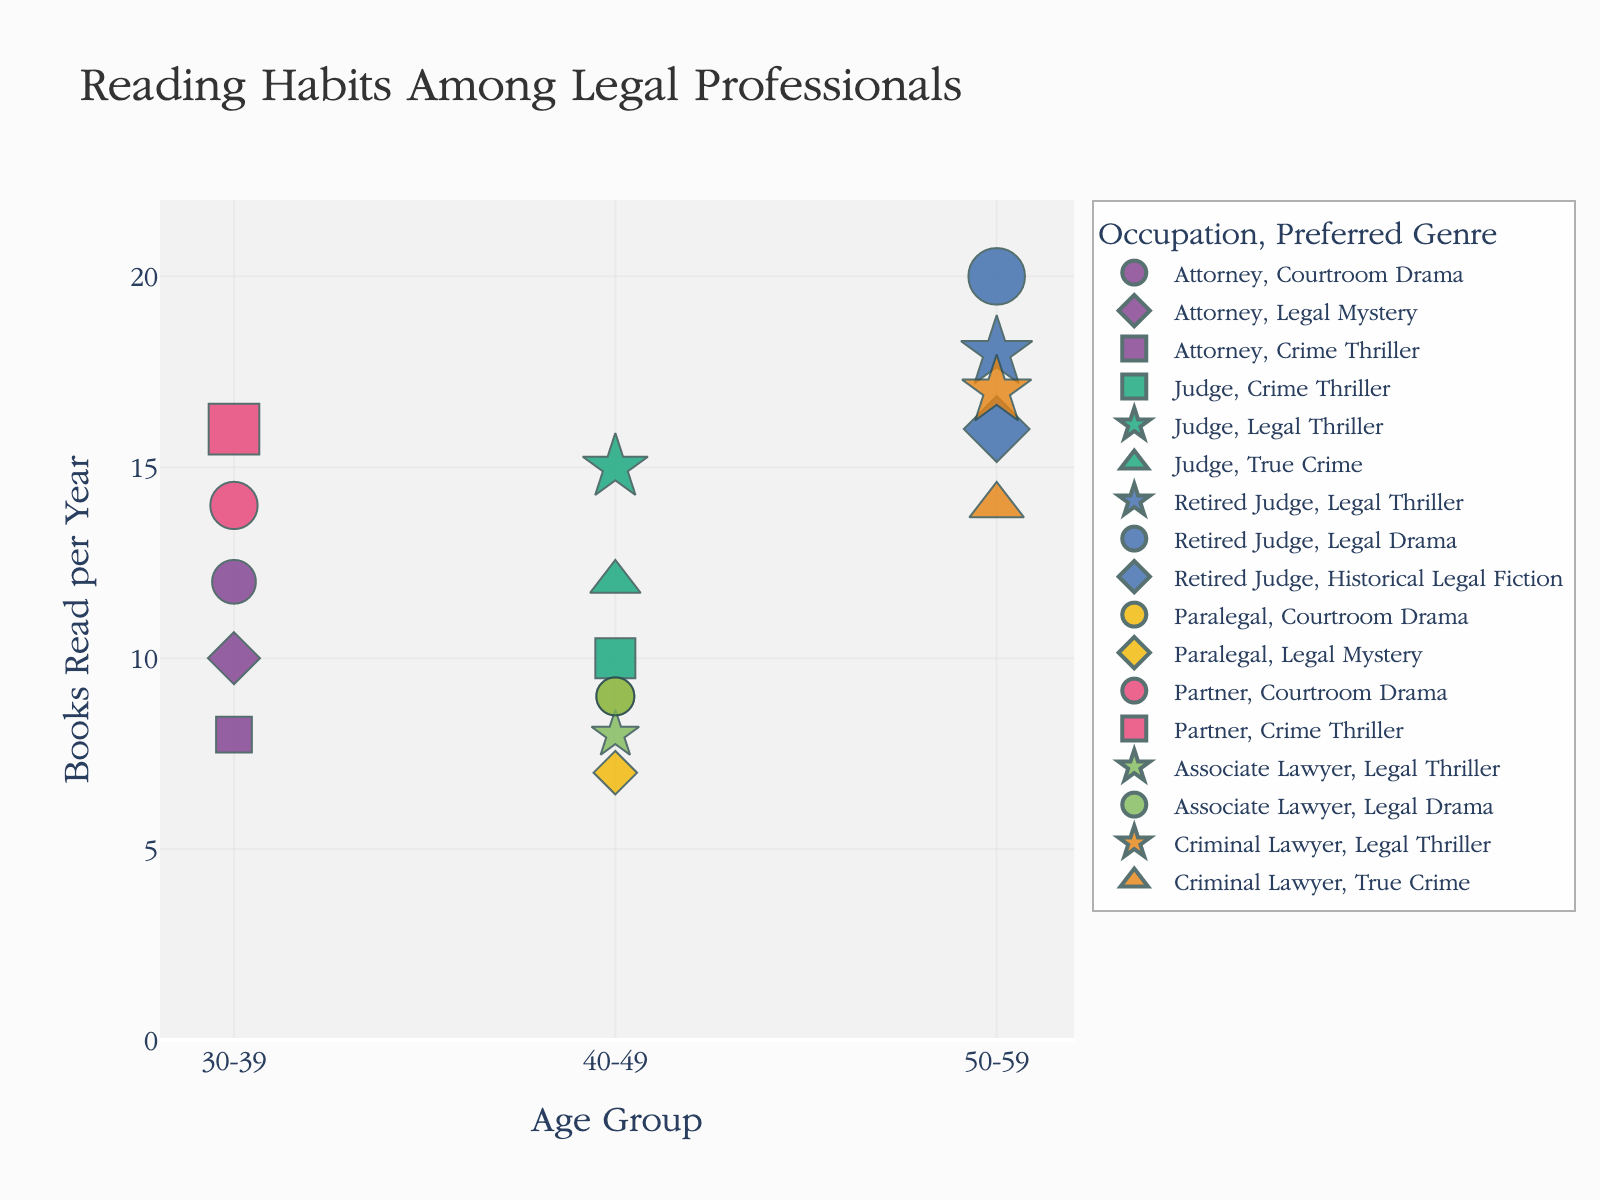How many age groups are shown in the figure? The x-axis appears to categorize data by different age groups. We count the distinct age groups visible on the x-axis.
Answer: 3 Which occupation reads the most books per year in the 50-59 age group? Look for the data points on the x-axis that fall under "50-59" and identify the occupation associated with the highest y-axis value (books read per year).
Answer: Retired Judge What is the range of books read per year by the 40-49 age group? To find the range, observe the minimum and maximum y-axis values for the data points in the "40-49" age category. Subtract the minimum value from the maximum value.
Answer: 15 - 7 = 8 Which preferred genre is most popular among the 30-39 age group? Check for the data points corresponding to "30-39" and see which preferred genre symbol appears most frequently.
Answer: Courtroom Drama Compare the average number of books read per year between Attorneys and Criminal Lawyers. First, identify all data points for Attorneys and Criminal Lawyers. Calculate the average number of books read per year for both groups by summing their y-values and dividing by the number of data points in each group. Compare the two averages.
Answer: Attorneys: (12+10+8+14+16) / 5 = 60/5 = 12, Criminal Lawyers: (14+17) / 2 = 31/2 = 15.5. Criminal Lawyers read more on average Which combination of occupation and preferred genre records the highest number of books read per year? Identify the data point with the highest y-value. Note the corresponding occupation and preferred genre from the hover data.
Answer: Retired Judge, Legal Drama Does the Crime Thriller genre appear equally popular in the 30-39 and 40-49 age groups? Compare the number of data points associated with the Crime Thriller genre in both the 30-39 and 40-49 age groups.
Answer: No, 2 in 30-39 and 1 in 40-49 Are there any preferred genres that are unique to an age group? Check each preferred genre symbol and see if they appear exclusively within one specific age group on the x-axis.
Answer: Historical Legal Fiction (50-59) What is the whole range of books read per year across all data points? Identify the overall minimum and maximum y-values by observing all data points, then calculate the range.
Answer: 20 - 7 = 13 Do any occupations have all their data points (irrespective of age groups) in just one preferred genre? Identify each occupation and observe if all corresponding data points fall under the same preferred genre.
Answer: No 